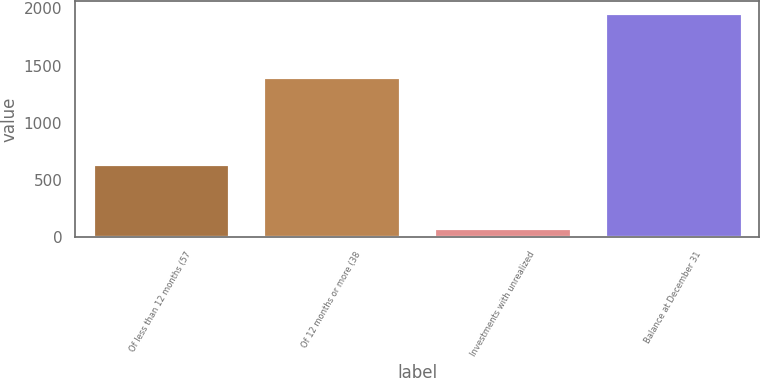Convert chart to OTSL. <chart><loc_0><loc_0><loc_500><loc_500><bar_chart><fcel>Of less than 12 months (57<fcel>Of 12 months or more (38<fcel>Investments with unrealized<fcel>Balance at December 31<nl><fcel>639<fcel>1401<fcel>79<fcel>1961<nl></chart> 